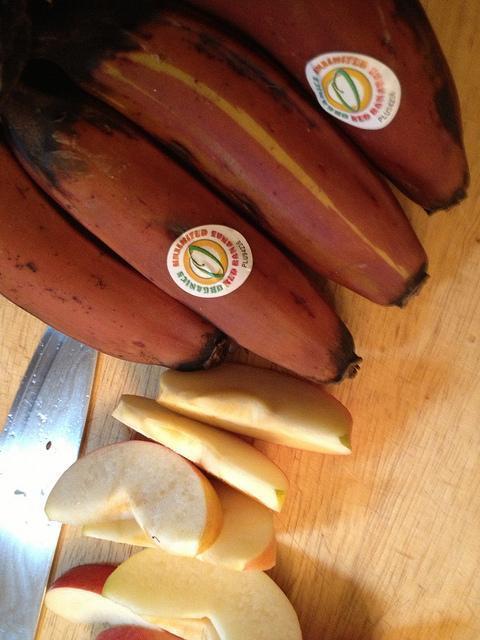How many knives can you see?
Give a very brief answer. 1. How many train cars are there?
Give a very brief answer. 0. 